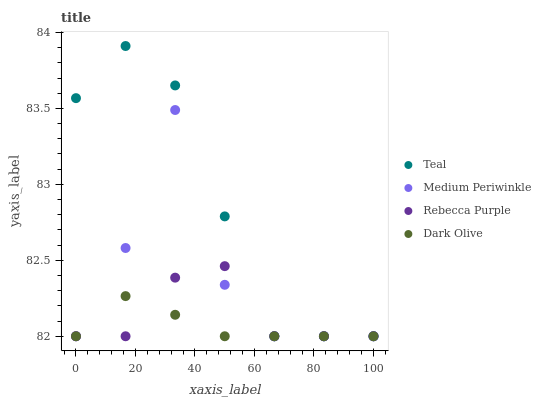Does Dark Olive have the minimum area under the curve?
Answer yes or no. Yes. Does Teal have the maximum area under the curve?
Answer yes or no. Yes. Does Medium Periwinkle have the minimum area under the curve?
Answer yes or no. No. Does Medium Periwinkle have the maximum area under the curve?
Answer yes or no. No. Is Dark Olive the smoothest?
Answer yes or no. Yes. Is Medium Periwinkle the roughest?
Answer yes or no. Yes. Is Rebecca Purple the smoothest?
Answer yes or no. No. Is Rebecca Purple the roughest?
Answer yes or no. No. Does Dark Olive have the lowest value?
Answer yes or no. Yes. Does Teal have the highest value?
Answer yes or no. Yes. Does Medium Periwinkle have the highest value?
Answer yes or no. No. Does Medium Periwinkle intersect Teal?
Answer yes or no. Yes. Is Medium Periwinkle less than Teal?
Answer yes or no. No. Is Medium Periwinkle greater than Teal?
Answer yes or no. No. 